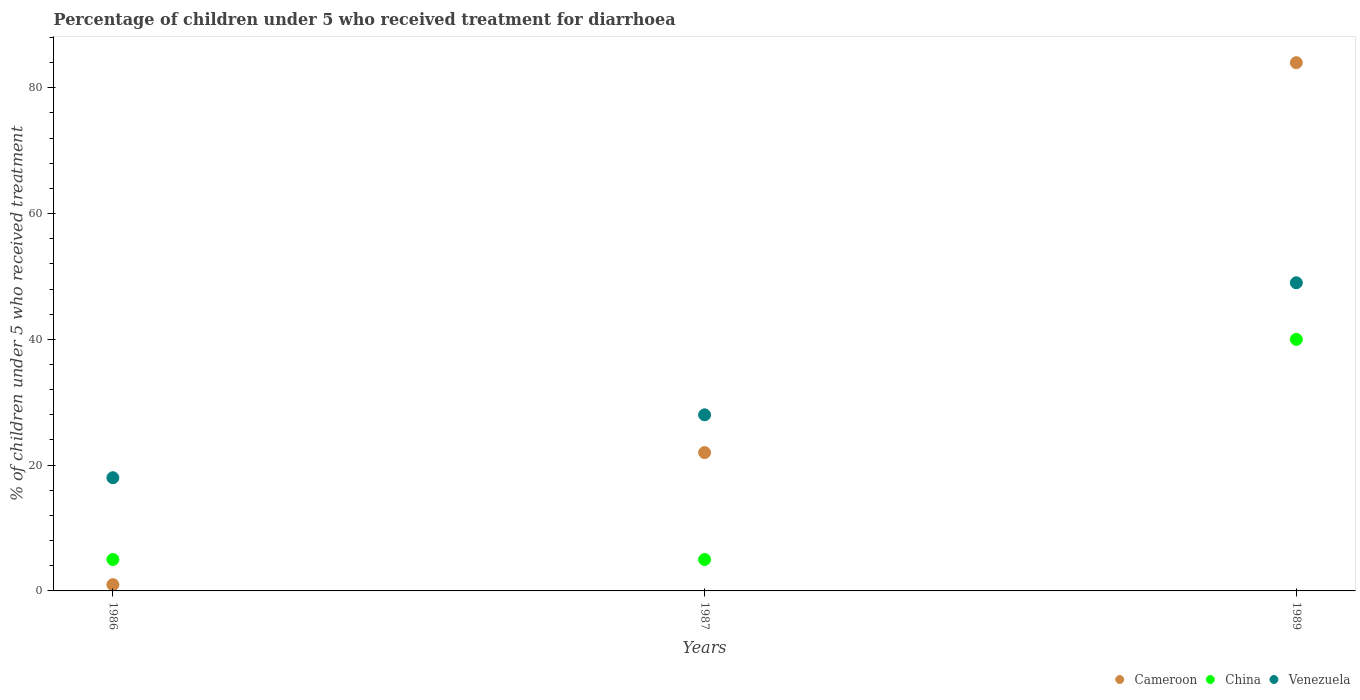In which year was the percentage of children who received treatment for diarrhoea  in China minimum?
Offer a terse response. 1986. What is the difference between the percentage of children who received treatment for diarrhoea  in Cameroon in 1987 and that in 1989?
Your response must be concise. -62. What is the difference between the percentage of children who received treatment for diarrhoea  in Cameroon in 1989 and the percentage of children who received treatment for diarrhoea  in China in 1987?
Give a very brief answer. 79. What is the average percentage of children who received treatment for diarrhoea  in Venezuela per year?
Give a very brief answer. 31.67. In the year 1987, what is the difference between the percentage of children who received treatment for diarrhoea  in Venezuela and percentage of children who received treatment for diarrhoea  in Cameroon?
Your response must be concise. 6. What is the ratio of the percentage of children who received treatment for diarrhoea  in Cameroon in 1986 to that in 1989?
Your answer should be compact. 0.01. Is the percentage of children who received treatment for diarrhoea  in Cameroon in 1987 less than that in 1989?
Offer a very short reply. Yes. Is the difference between the percentage of children who received treatment for diarrhoea  in Venezuela in 1986 and 1987 greater than the difference between the percentage of children who received treatment for diarrhoea  in Cameroon in 1986 and 1987?
Your answer should be compact. Yes. What is the difference between the highest and the second highest percentage of children who received treatment for diarrhoea  in Venezuela?
Offer a terse response. 21. In how many years, is the percentage of children who received treatment for diarrhoea  in China greater than the average percentage of children who received treatment for diarrhoea  in China taken over all years?
Offer a terse response. 1. Is the sum of the percentage of children who received treatment for diarrhoea  in Venezuela in 1986 and 1989 greater than the maximum percentage of children who received treatment for diarrhoea  in Cameroon across all years?
Your answer should be very brief. No. How many years are there in the graph?
Provide a succinct answer. 3. What is the difference between two consecutive major ticks on the Y-axis?
Give a very brief answer. 20. Does the graph contain any zero values?
Make the answer very short. No. Where does the legend appear in the graph?
Your answer should be compact. Bottom right. How many legend labels are there?
Make the answer very short. 3. What is the title of the graph?
Provide a succinct answer. Percentage of children under 5 who received treatment for diarrhoea. What is the label or title of the X-axis?
Your response must be concise. Years. What is the label or title of the Y-axis?
Your answer should be very brief. % of children under 5 who received treatment. What is the % of children under 5 who received treatment in Cameroon in 1986?
Make the answer very short. 1. What is the % of children under 5 who received treatment in Venezuela in 1986?
Keep it short and to the point. 18. What is the % of children under 5 who received treatment in Cameroon in 1987?
Provide a succinct answer. 22. What is the % of children under 5 who received treatment of China in 1987?
Make the answer very short. 5. What is the % of children under 5 who received treatment of Cameroon in 1989?
Your answer should be compact. 84. What is the % of children under 5 who received treatment of China in 1989?
Make the answer very short. 40. Across all years, what is the maximum % of children under 5 who received treatment in China?
Offer a very short reply. 40. Across all years, what is the minimum % of children under 5 who received treatment of Cameroon?
Provide a short and direct response. 1. What is the total % of children under 5 who received treatment in Cameroon in the graph?
Keep it short and to the point. 107. What is the total % of children under 5 who received treatment in Venezuela in the graph?
Provide a succinct answer. 95. What is the difference between the % of children under 5 who received treatment in Cameroon in 1986 and that in 1989?
Offer a terse response. -83. What is the difference between the % of children under 5 who received treatment of China in 1986 and that in 1989?
Offer a very short reply. -35. What is the difference between the % of children under 5 who received treatment in Venezuela in 1986 and that in 1989?
Offer a very short reply. -31. What is the difference between the % of children under 5 who received treatment in Cameroon in 1987 and that in 1989?
Your response must be concise. -62. What is the difference between the % of children under 5 who received treatment in China in 1987 and that in 1989?
Ensure brevity in your answer.  -35. What is the difference between the % of children under 5 who received treatment of Venezuela in 1987 and that in 1989?
Ensure brevity in your answer.  -21. What is the difference between the % of children under 5 who received treatment of China in 1986 and the % of children under 5 who received treatment of Venezuela in 1987?
Your answer should be compact. -23. What is the difference between the % of children under 5 who received treatment in Cameroon in 1986 and the % of children under 5 who received treatment in China in 1989?
Provide a short and direct response. -39. What is the difference between the % of children under 5 who received treatment in Cameroon in 1986 and the % of children under 5 who received treatment in Venezuela in 1989?
Give a very brief answer. -48. What is the difference between the % of children under 5 who received treatment in China in 1986 and the % of children under 5 who received treatment in Venezuela in 1989?
Make the answer very short. -44. What is the difference between the % of children under 5 who received treatment in China in 1987 and the % of children under 5 who received treatment in Venezuela in 1989?
Give a very brief answer. -44. What is the average % of children under 5 who received treatment in Cameroon per year?
Your answer should be very brief. 35.67. What is the average % of children under 5 who received treatment in China per year?
Provide a succinct answer. 16.67. What is the average % of children under 5 who received treatment of Venezuela per year?
Keep it short and to the point. 31.67. In the year 1986, what is the difference between the % of children under 5 who received treatment of Cameroon and % of children under 5 who received treatment of China?
Offer a very short reply. -4. In the year 1987, what is the difference between the % of children under 5 who received treatment in Cameroon and % of children under 5 who received treatment in China?
Offer a terse response. 17. In the year 1987, what is the difference between the % of children under 5 who received treatment in Cameroon and % of children under 5 who received treatment in Venezuela?
Keep it short and to the point. -6. In the year 1987, what is the difference between the % of children under 5 who received treatment in China and % of children under 5 who received treatment in Venezuela?
Keep it short and to the point. -23. In the year 1989, what is the difference between the % of children under 5 who received treatment in Cameroon and % of children under 5 who received treatment in China?
Your answer should be compact. 44. In the year 1989, what is the difference between the % of children under 5 who received treatment of China and % of children under 5 who received treatment of Venezuela?
Offer a very short reply. -9. What is the ratio of the % of children under 5 who received treatment of Cameroon in 1986 to that in 1987?
Your answer should be compact. 0.05. What is the ratio of the % of children under 5 who received treatment in Venezuela in 1986 to that in 1987?
Provide a succinct answer. 0.64. What is the ratio of the % of children under 5 who received treatment in Cameroon in 1986 to that in 1989?
Make the answer very short. 0.01. What is the ratio of the % of children under 5 who received treatment in China in 1986 to that in 1989?
Your answer should be very brief. 0.12. What is the ratio of the % of children under 5 who received treatment of Venezuela in 1986 to that in 1989?
Your answer should be very brief. 0.37. What is the ratio of the % of children under 5 who received treatment in Cameroon in 1987 to that in 1989?
Offer a terse response. 0.26. What is the ratio of the % of children under 5 who received treatment of China in 1987 to that in 1989?
Make the answer very short. 0.12. What is the ratio of the % of children under 5 who received treatment in Venezuela in 1987 to that in 1989?
Provide a short and direct response. 0.57. What is the difference between the highest and the second highest % of children under 5 who received treatment of Venezuela?
Ensure brevity in your answer.  21. What is the difference between the highest and the lowest % of children under 5 who received treatment in Cameroon?
Your answer should be very brief. 83. 